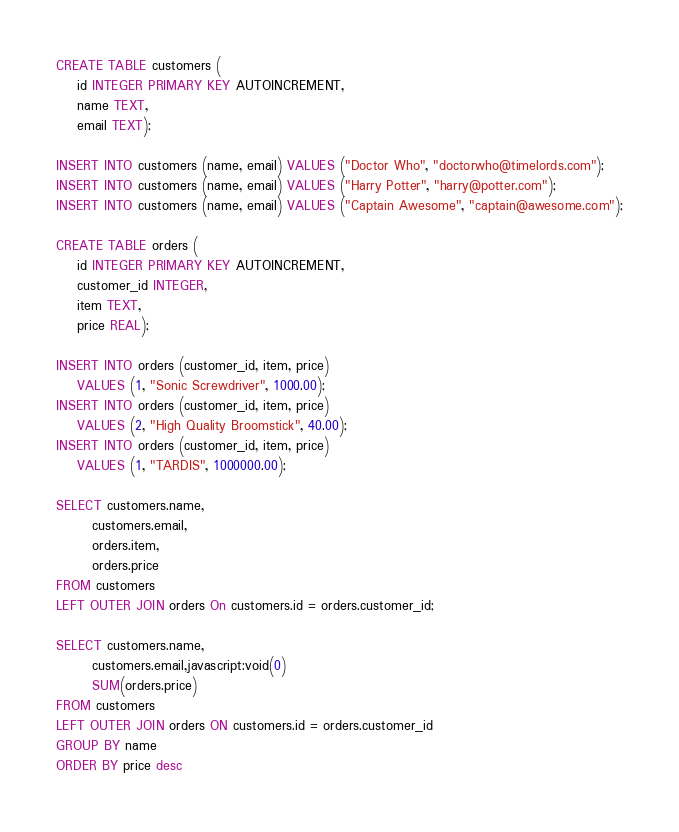Convert code to text. <code><loc_0><loc_0><loc_500><loc_500><_SQL_>CREATE TABLE customers (
    id INTEGER PRIMARY KEY AUTOINCREMENT,
    name TEXT,
    email TEXT);

INSERT INTO customers (name, email) VALUES ("Doctor Who", "doctorwho@timelords.com");
INSERT INTO customers (name, email) VALUES ("Harry Potter", "harry@potter.com");
INSERT INTO customers (name, email) VALUES ("Captain Awesome", "captain@awesome.com");

CREATE TABLE orders (
    id INTEGER PRIMARY KEY AUTOINCREMENT,
    customer_id INTEGER,
    item TEXT,
    price REAL);

INSERT INTO orders (customer_id, item, price)
    VALUES (1, "Sonic Screwdriver", 1000.00);
INSERT INTO orders (customer_id, item, price)
    VALUES (2, "High Quality Broomstick", 40.00);
INSERT INTO orders (customer_id, item, price)
    VALUES (1, "TARDIS", 1000000.00);

SELECT customers.name,
       customers.email,
       orders.item,
       orders.price
FROM customers
LEFT OUTER JOIN orders On customers.id = orders.customer_id;

SELECT customers.name,
       customers.email,javascript:void(0)
       SUM(orders.price)
FROM customers
LEFT OUTER JOIN orders ON customers.id = orders.customer_id
GROUP BY name
ORDER BY price desc
</code> 